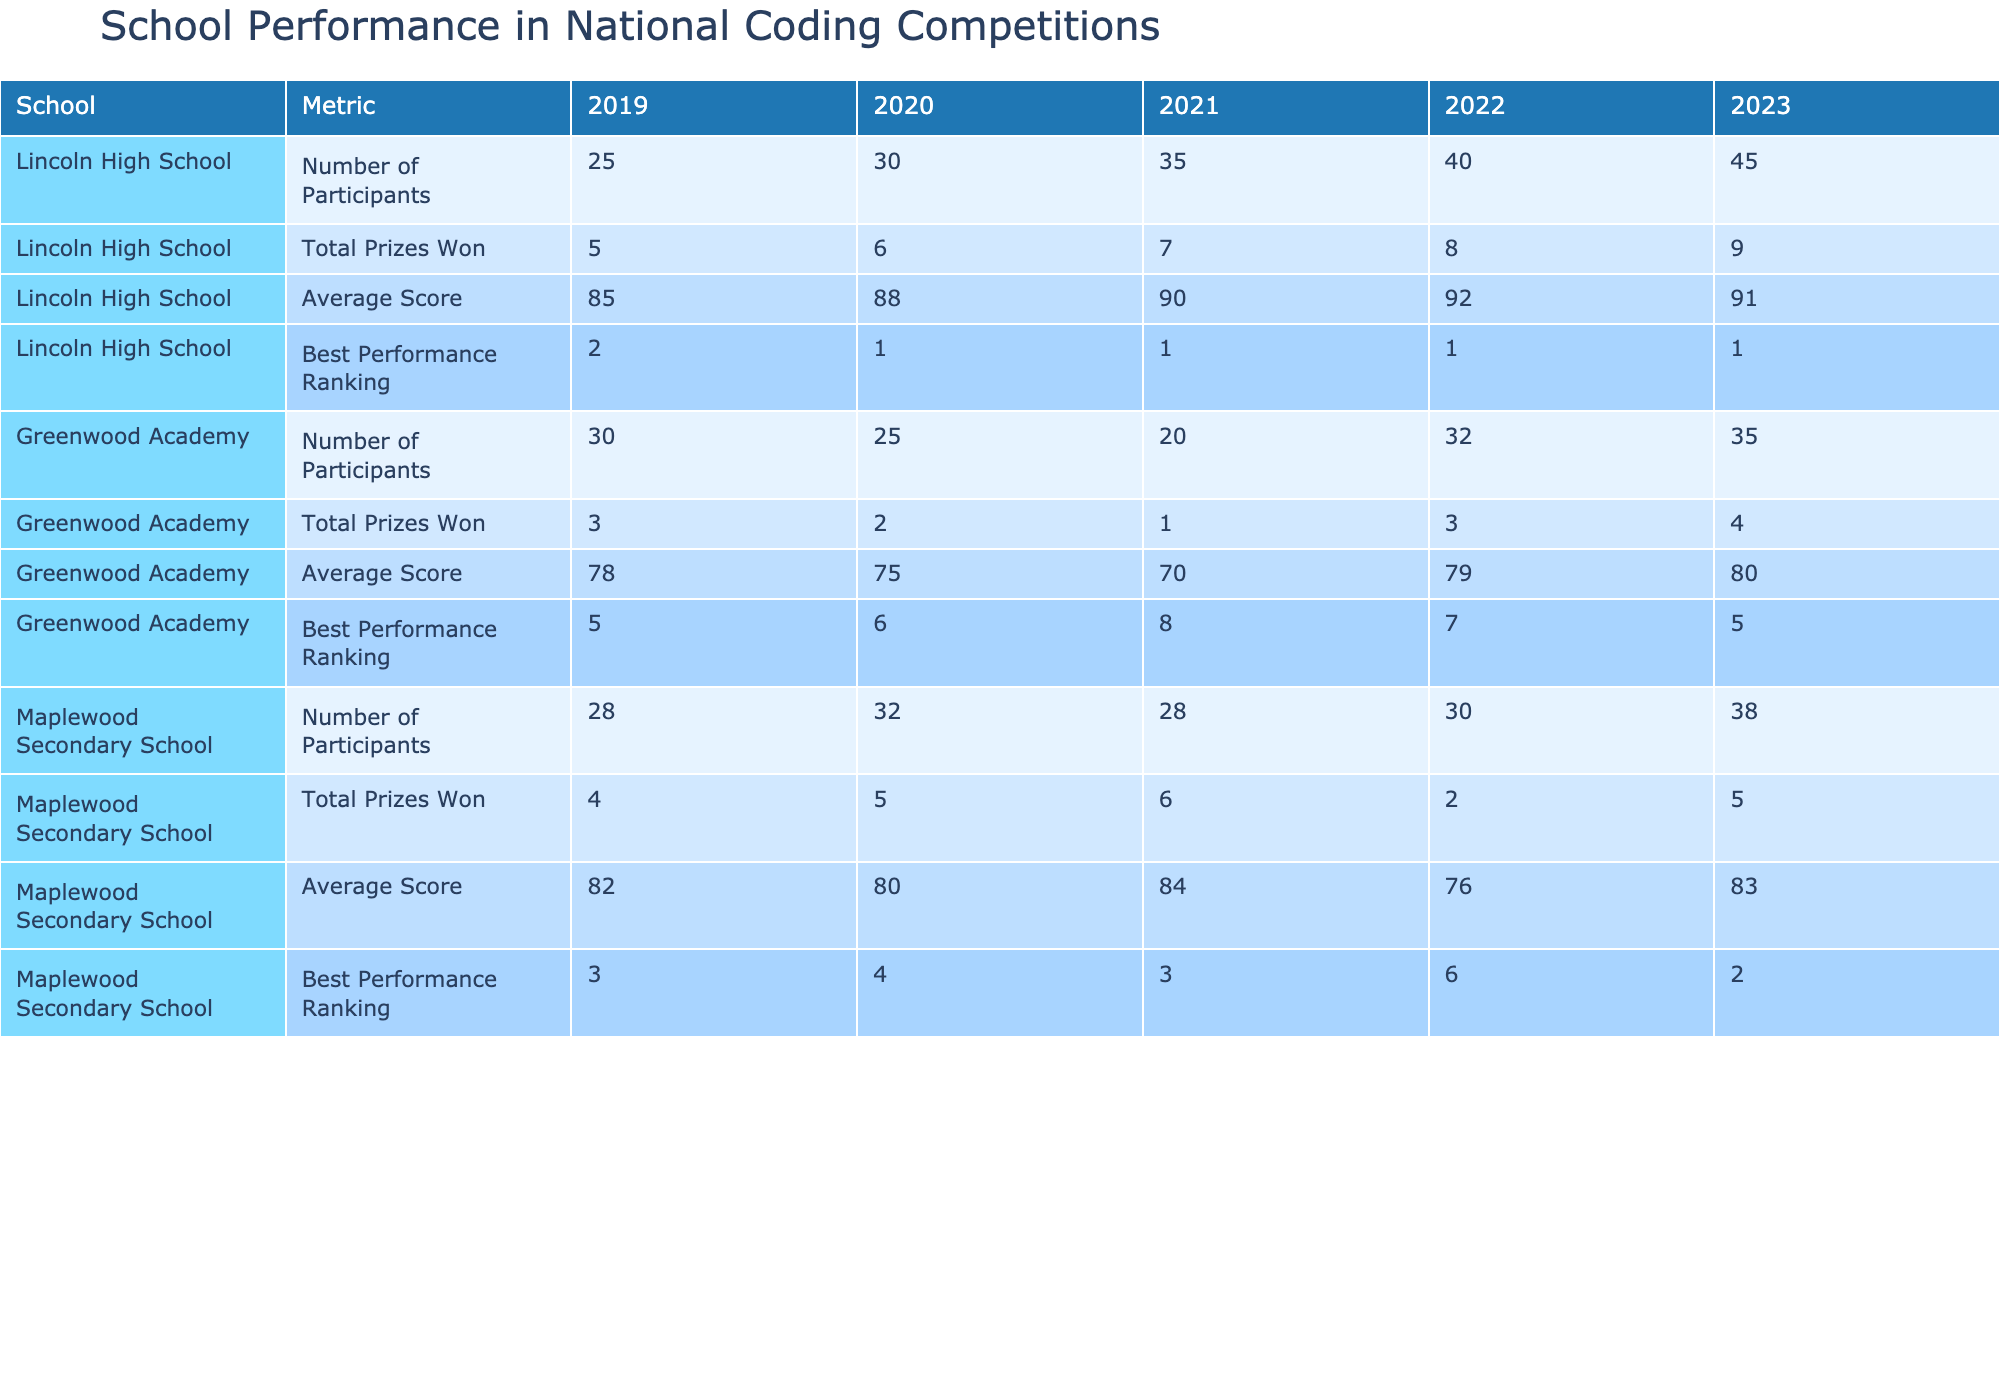What was Lincoln High School's average score in 2021? The average score for Lincoln High School in 2021 can be found in the table under the 'Average Score' metric for the year 2021. It is listed as 90.
Answer: 90 Which school had the best performance ranking in 2020? To find the best performance ranking in 2020, I check the 'Best Performance Ranking' column for that year. Lincoln High School has a ranking of 1, which is the best.
Answer: Lincoln High School What is the total number of prizes won by Maplewood Secondary School from 2019 to 2023? The total number of prizes won can be calculated by adding the values for Maplewood Secondary School across all five years: 4 + 5 + 6 + 2 + 5 = 22.
Answer: 22 Did Greenwood Academy improve its average score from 2019 to 2023? To answer this, I need to compare the average scores for Greenwood Academy in both years. In 2019, the average score was 78 and in 2023 it was 80, indicating an improvement.
Answer: Yes What was the change in the total number of participants from 2020 to 2023 for Lincoln High School? I need to find the number of participants for Lincoln High School in both 2020 and 2023. In 2020, the number of participants was 30, and in 2023 it increased to 45. The change is 45 - 30 = 15.
Answer: 15 Which school consistently had the highest average score across all years? To determine this, I will check the average scores for each school from 2019 to 2023. Lincoln High School had scores of 85, 88, 90, 92, and 91, consistently being the highest compared to the other schools.
Answer: Lincoln High School How many total prizes did Lincoln High School win from 2019 to 2022? To find this, I add up the total prizes won by Lincoln High School from 2019 through 2022: 5 + 6 + 7 + 8 = 26.
Answer: 26 Was there a decrease in the number of participants for Greenwood Academy from 2020 to 2021? For Greenwood Academy, I need to look at the participants in 2020, which were 25, and in 2021, which were 20. This shows a decrease of 5 participants.
Answer: Yes What is the average best performance ranking for Maplewood Secondary School over the years? I will find the best performance rankings for Maplewood Secondary School from 2019 to 2023, which are 3, 4, 3, 6, and 2. The average ranking is calculated as (3 + 4 + 3 + 6 + 2) / 5 = 3.6.
Answer: 3.6 